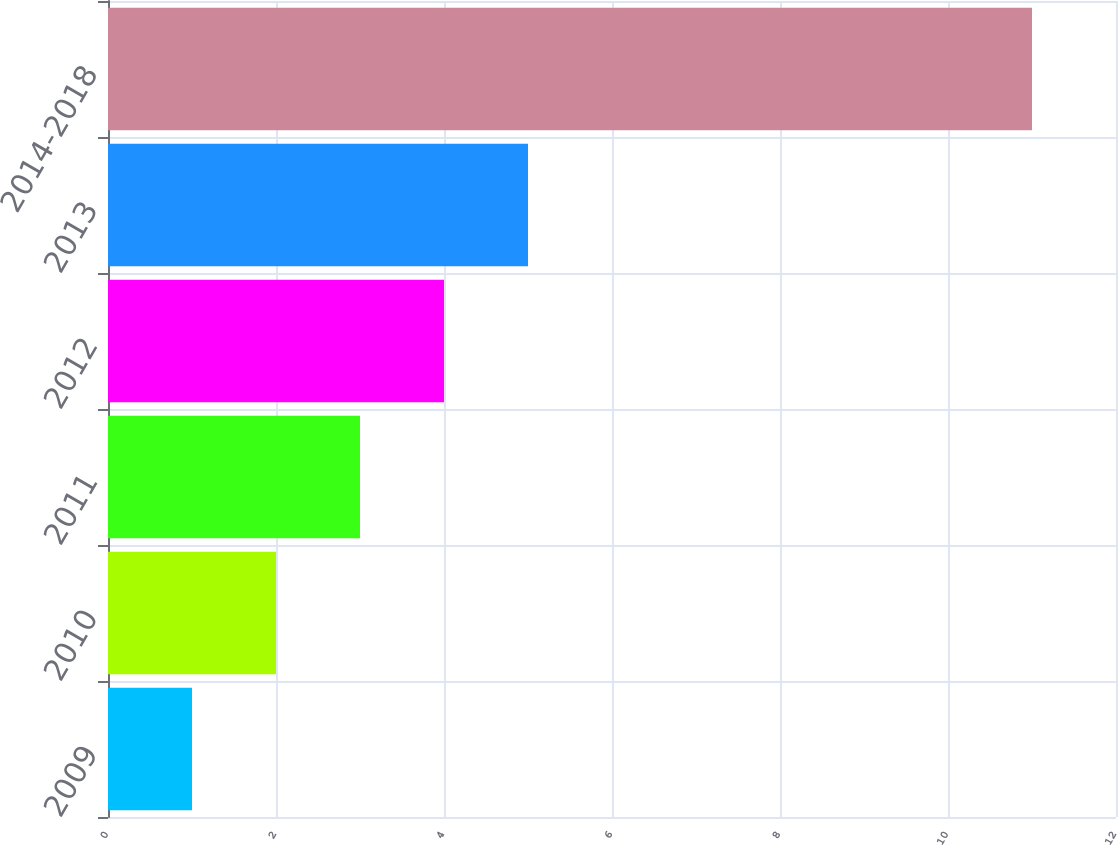<chart> <loc_0><loc_0><loc_500><loc_500><bar_chart><fcel>2009<fcel>2010<fcel>2011<fcel>2012<fcel>2013<fcel>2014-2018<nl><fcel>1<fcel>2<fcel>3<fcel>4<fcel>5<fcel>11<nl></chart> 